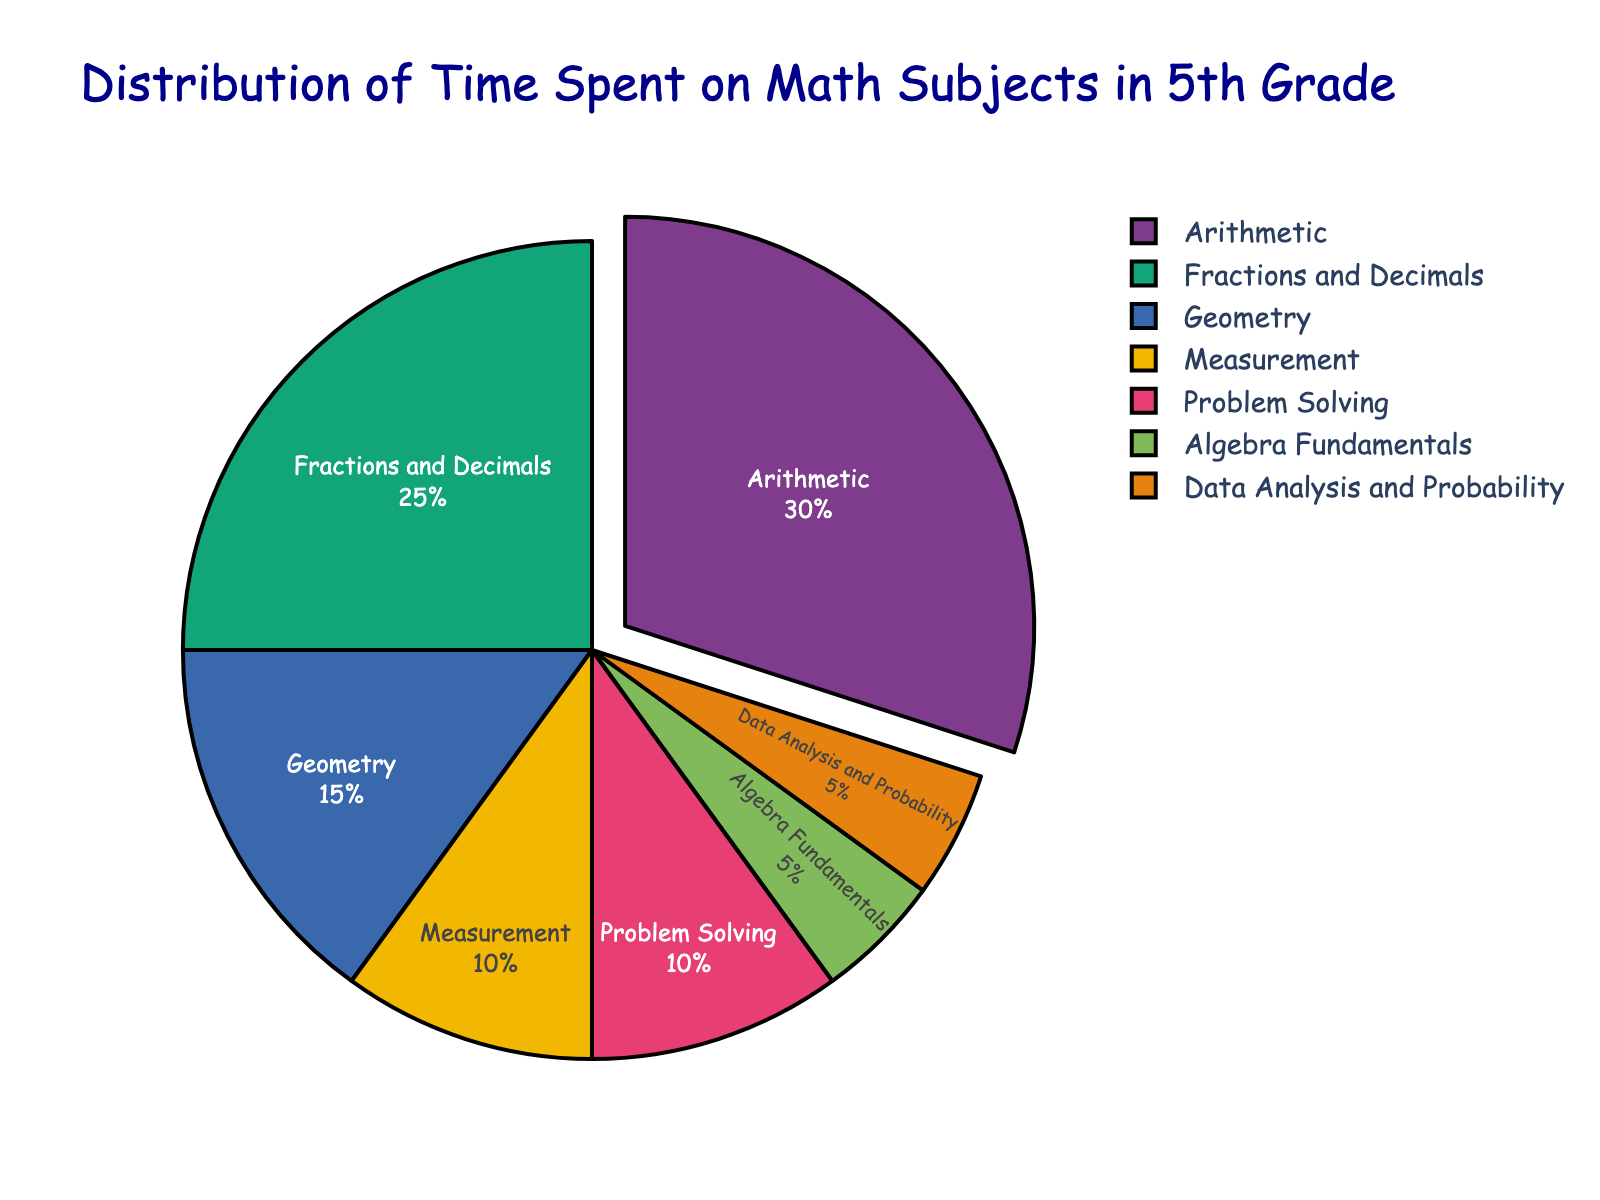What is the subject with the highest percentage of time spent? By observing the pie chart, the section that is slightly pulled out represents the subject with the highest time percentage. The largest segment corresponds to "Arithmetic" with 30%.
Answer: Arithmetic Which two subjects have the same percentage of time spent, and what is that percentage? By examining the chart, we identify two segments of equal size. "Algebra Fundamentals" and "Data Analysis and Probability" each represent 5% of the time.
Answer: Algebra Fundamentals and Data Analysis and Probability, 5% How much more time is spent on Fractions and Decimals compared to Geometry? By comparing the chart segments, Fractions and Decimals take up 25% and Geometry takes up 15%. The difference is 25% - 15% = 10%.
Answer: 10% What is the total percentage of time spent on Problem Solving and Measurement combined? Adding the percentages of Problem Solving (10%) and Measurement (10%) yields a total of 10% + 10% = 20%.
Answer: 20% Which subject has a larger time percentage, Geometry or Measurement? By examining the chart segments, Geometry has a larger percentage of 15% compared to Measurement's 10%.
Answer: Geometry Rank the subjects from highest to lowest in terms of percentage of time spent. By observing the chart and comparing segment sizes: 1. Arithmetic (30%), 2. Fractions and Decimals (25%), 3. Geometry (15%), 4. Measurement (10%), 5. Problem Solving (10%), 6. Algebra Fundamentals (5%), 7. Data Analysis and Probability (5%).
Answer: Arithmetic > Fractions and Decimals > Geometry > Measurement > Problem Solving > Algebra Fundamentals, Data Analysis and Probability What percentage of time is spent on subjects other than Arithmetic? Subtracting Arithmetic's percentage from 100%: 100% - 30% = 70%.
Answer: 70% How does the percentage of time spent on Problem Solving compare with the percentage of time spent on Algebra Fundamentals? By comparing the chart segments, Problem Solving at 10% is twice that of Algebra Fundamentals at 5%.
Answer: Problem Solving is twice as much What is the combined percentage of time spent on Geometry, Measurement, and Data Analysis and Probability? Summing the percentages: Geometry (15%) + Measurement (10%) + Data Analysis and Probability (5%) = 30%.
Answer: 30% How much more time is spent on Fractions and Decimals compared to Fractions and Decimals and Algebra Fundamentals together? First, summing Fractions and Decimals and Algebra Fundamentals: 25% + 5% = 30%. Then subtracting Fractions and Decimals: 30% - 25% = 5%.
Answer: 5% 